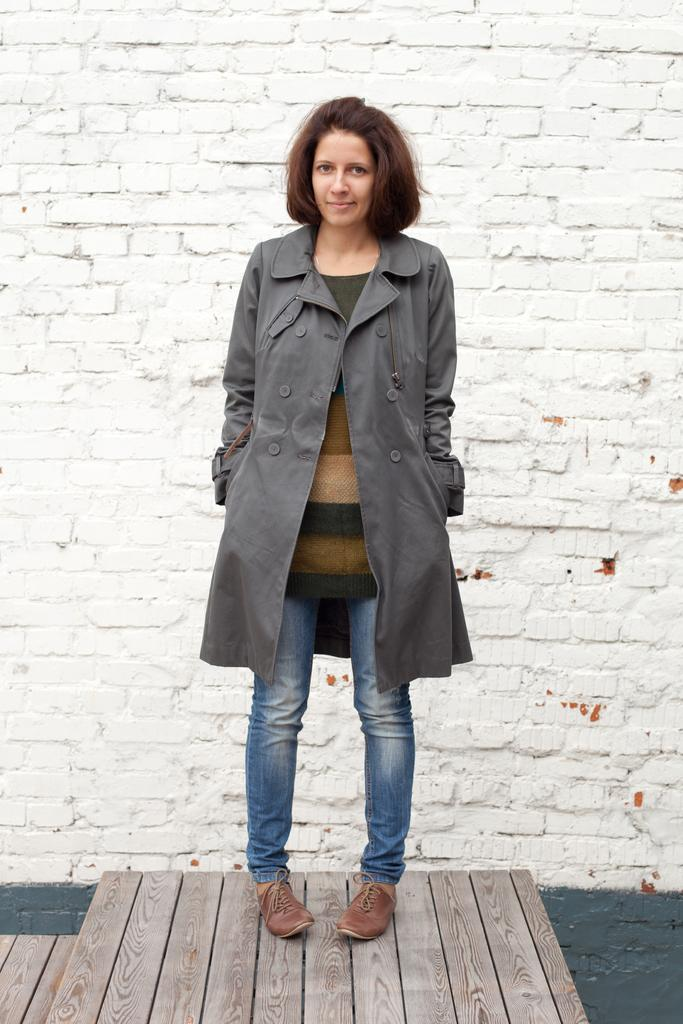Who is present in the image? There is a woman in the image. What is the woman wearing? The woman is wearing a grey jacket. What is the woman doing in the image? The woman is standing. What can be seen in the background of the image? There is a wall in the background of the image. What type of floor is visible in the image? There is a wooden floor in the image. What type of quilt is being used to protest in the image? There is no quilt or protest present in the image; it features a woman standing in a room with a wall and wooden floor. 